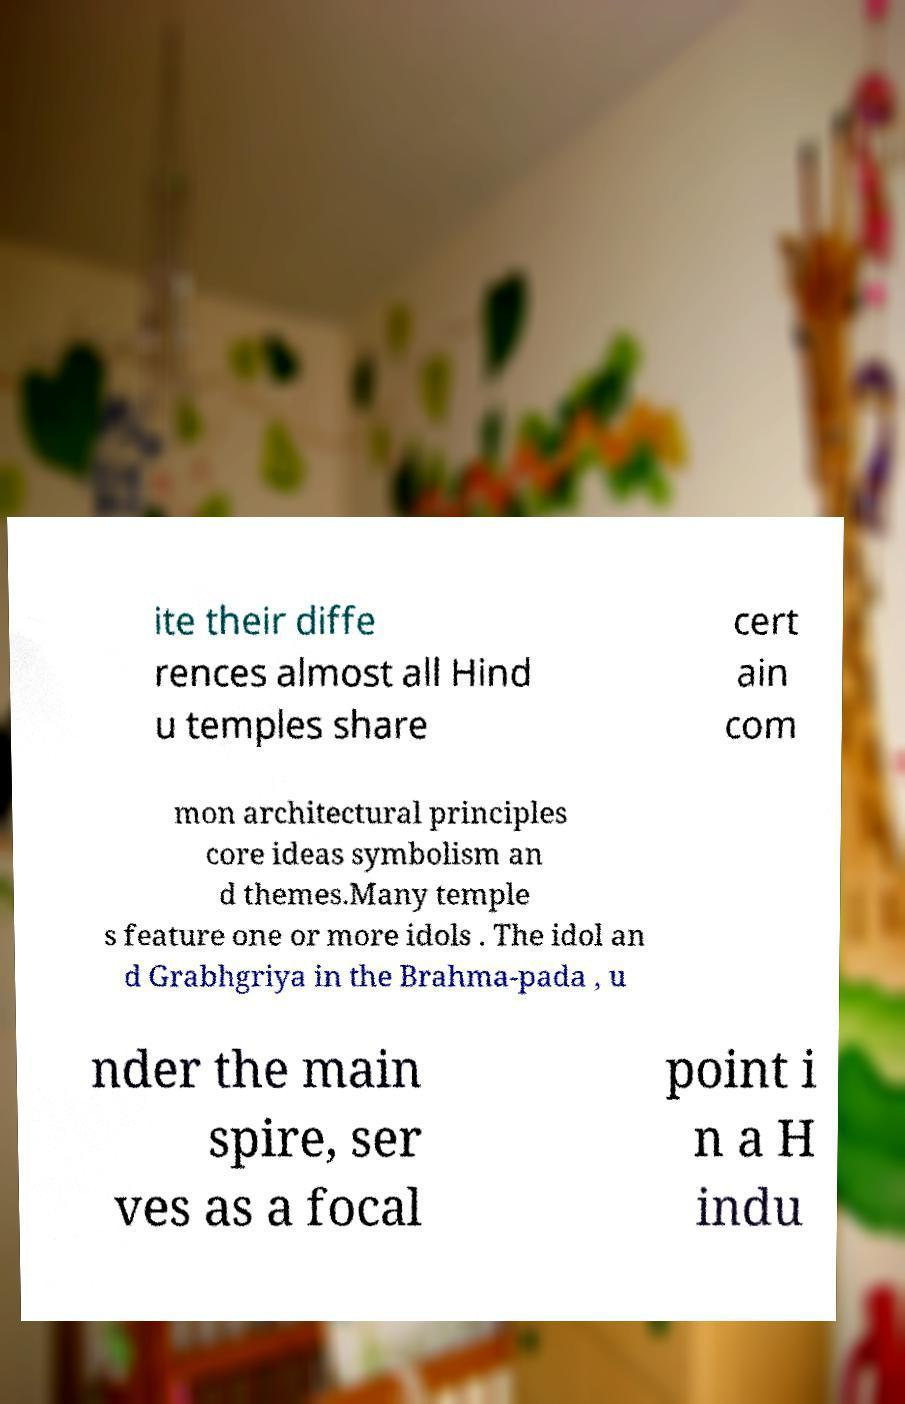There's text embedded in this image that I need extracted. Can you transcribe it verbatim? ite their diffe rences almost all Hind u temples share cert ain com mon architectural principles core ideas symbolism an d themes.Many temple s feature one or more idols . The idol an d Grabhgriya in the Brahma-pada , u nder the main spire, ser ves as a focal point i n a H indu 